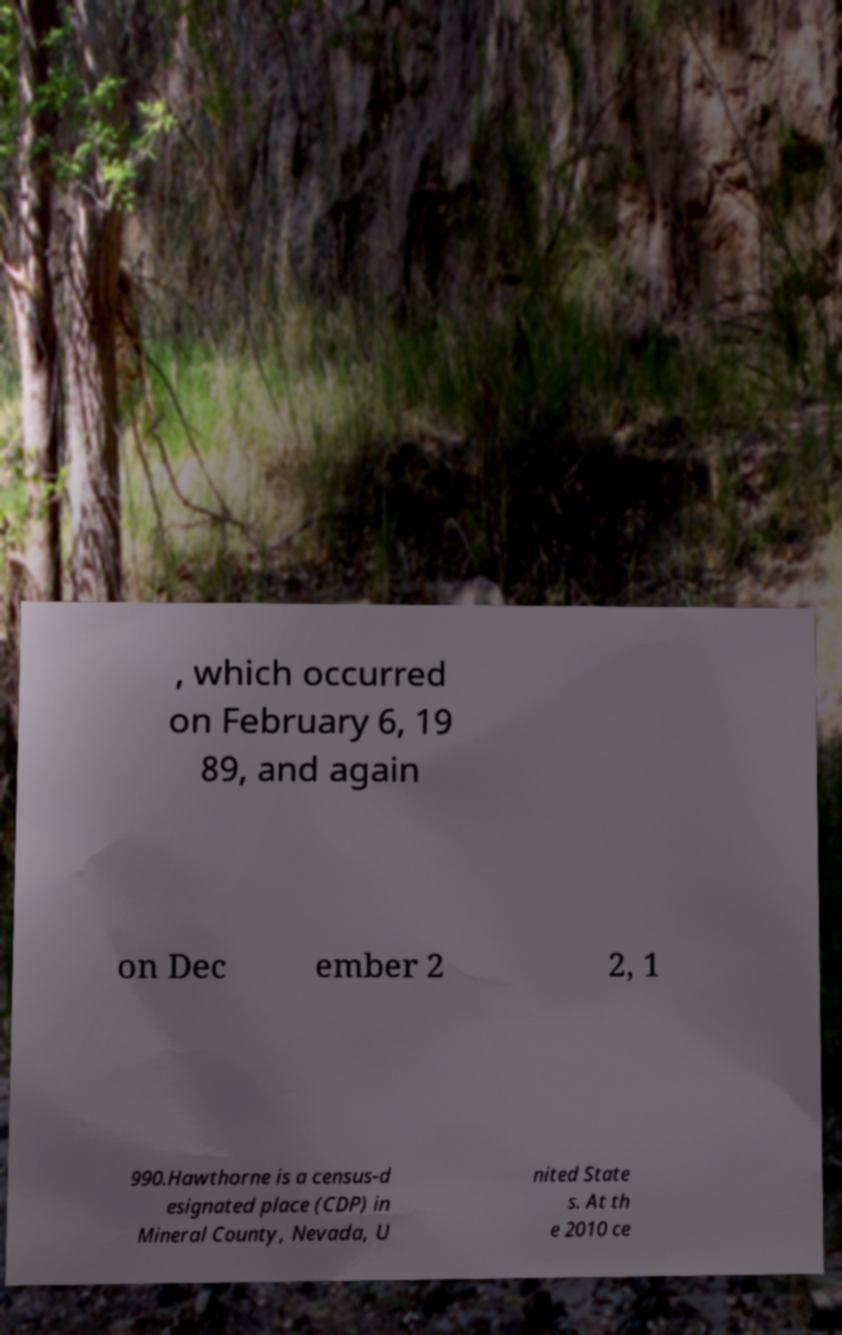There's text embedded in this image that I need extracted. Can you transcribe it verbatim? , which occurred on February 6, 19 89, and again on Dec ember 2 2, 1 990.Hawthorne is a census-d esignated place (CDP) in Mineral County, Nevada, U nited State s. At th e 2010 ce 